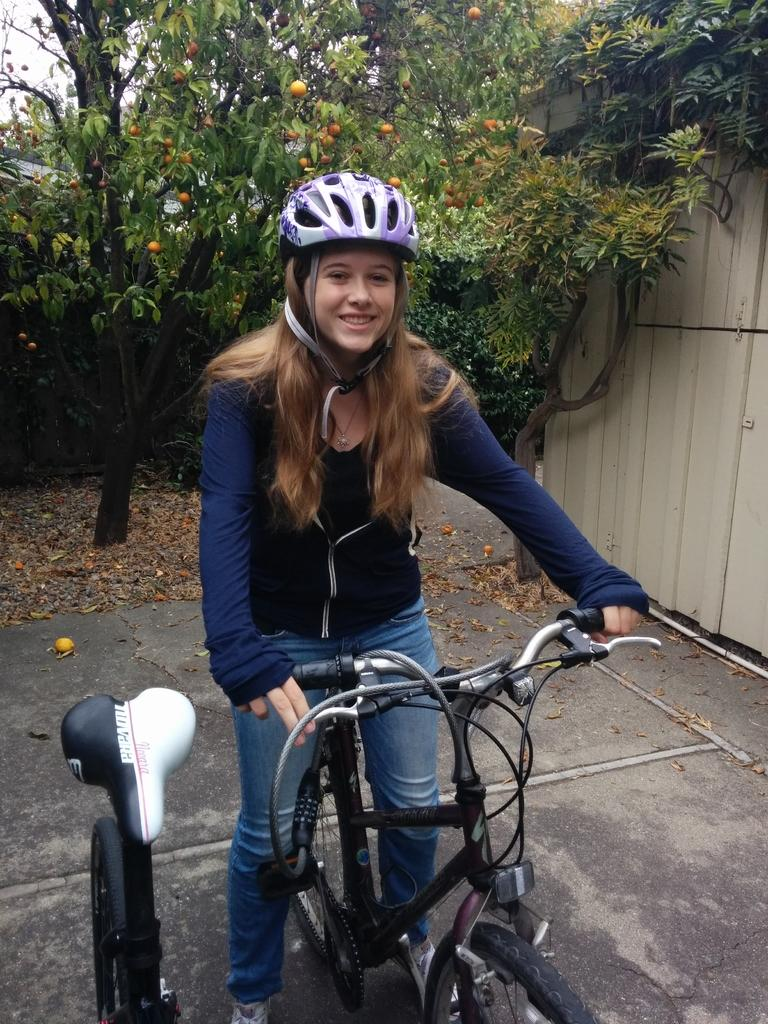Who is the main subject in the image? There is a woman in the image. What is the woman doing in the image? The woman is riding a bicycle. What safety precaution is the woman taking while riding the bicycle? The woman is wearing a helmet. What can be seen in the background of the image? There is a tree with fruits in the image. What type of teeth can be seen in the image? There are no teeth visible in the image; it features a woman riding a bicycle and a tree with fruits. 